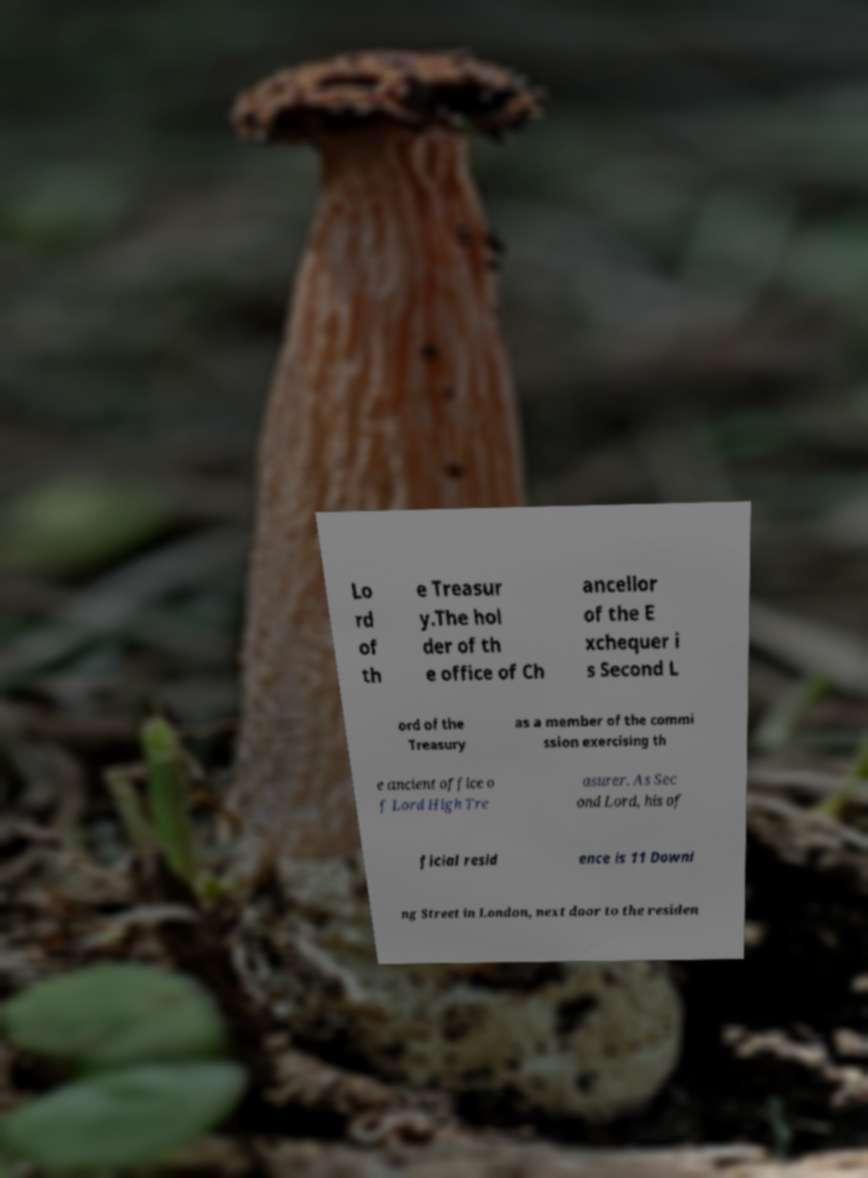For documentation purposes, I need the text within this image transcribed. Could you provide that? Lo rd of th e Treasur y.The hol der of th e office of Ch ancellor of the E xchequer i s Second L ord of the Treasury as a member of the commi ssion exercising th e ancient office o f Lord High Tre asurer. As Sec ond Lord, his of ficial resid ence is 11 Downi ng Street in London, next door to the residen 